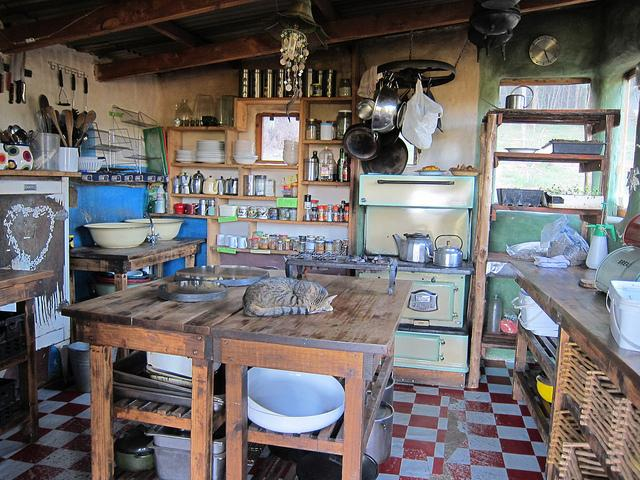What is in the kitchen but unnecessary for cooking or baking? cat 